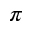Convert formula to latex. <formula><loc_0><loc_0><loc_500><loc_500>\pi</formula> 